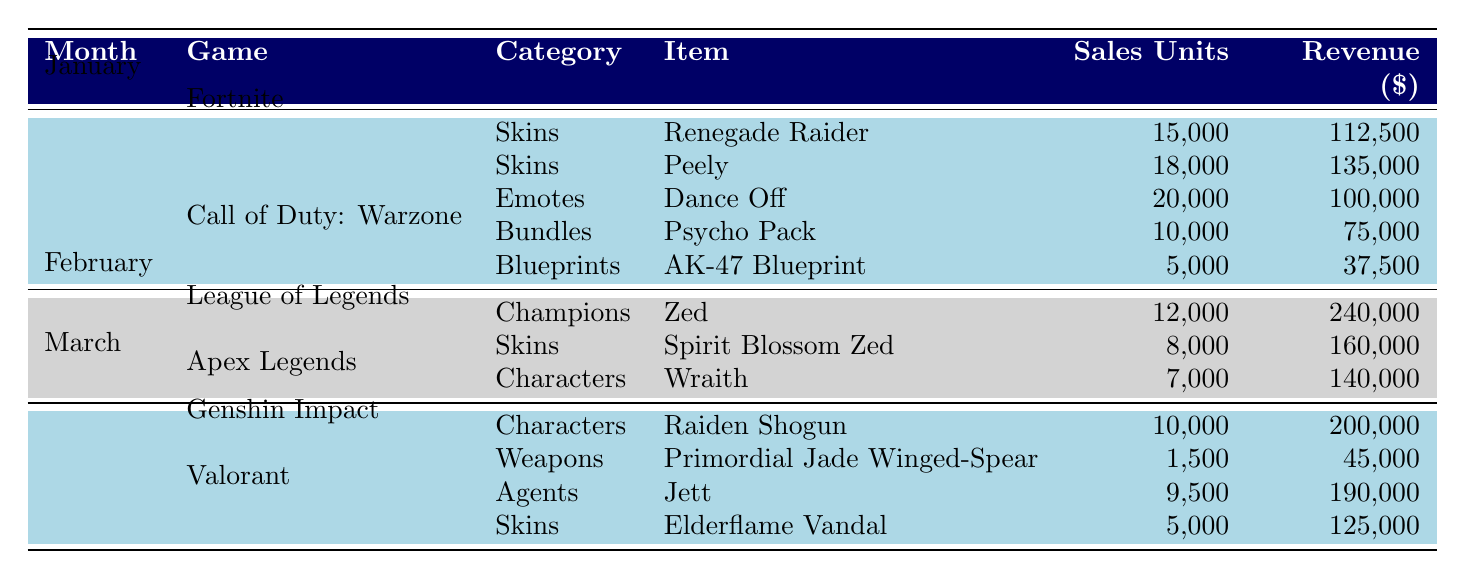What were the total sales units for Fortnite in January? In January, Fortnite had three items listed: Renegade Raider with 15,000 units, Peely with 18,000 units, and Dance Off with 20,000 units. Adding these together gives 15,000 + 18,000 + 20,000 = 53,000.
Answer: 53000 Which item generated the highest revenue in February? In February for League of Legends, Zed generated $240,000, and Spirit Blossom Zed generated $160,000. For Apex Legends, Wraith generated $140,000. The highest revenue among these is $240,000.
Answer: 240000 Did Genshin Impact release any weapons in January? Looking at the data for Genshin Impact in January, there are no entries under that game in that month. Therefore, there were no weapon sales for Genshin Impact in January.
Answer: No What is the total revenue from items sold in March? In March, Genshin Impact had Raiden Shogun with $200,000 and Primordial Jade Winged-Spear with $45,000, while Valorant had Jett with $190,000 and Elderflame Vandal with $125,000. Summing these revenues gives $200,000 + $45,000 + $190,000 + $125,000 = $560,000.
Answer: 560000 Which game had the most items sold across all months? In January, Fortnite had 3 items; Call of Duty: Warzone had 2 items. In February, League of Legends had 2 items and Apex Legends had 1 item. In March, Genshin Impact had 2 items and Valorant had 2 items. Therefore, Fortnite had the most items sold, with a total of 3.
Answer: Fortnite What percentage of total sales units in January came from the Dance Off emote in Fortnite? The total sales units for January in Fortnite is 53,000. Dance Off had 20,000 sales units. To find the percentage, divide 20,000 by 53,000 and multiply by 100: (20,000/53,000) * 100 ≈ 37.74%.
Answer: Approximately 37.74% 